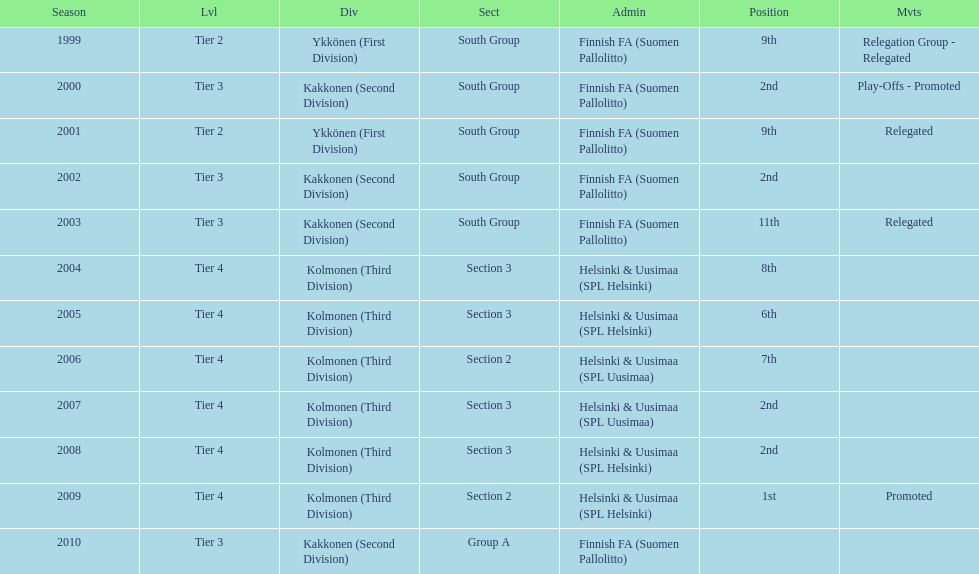How many consecutive times did they play in tier 4? 6. 